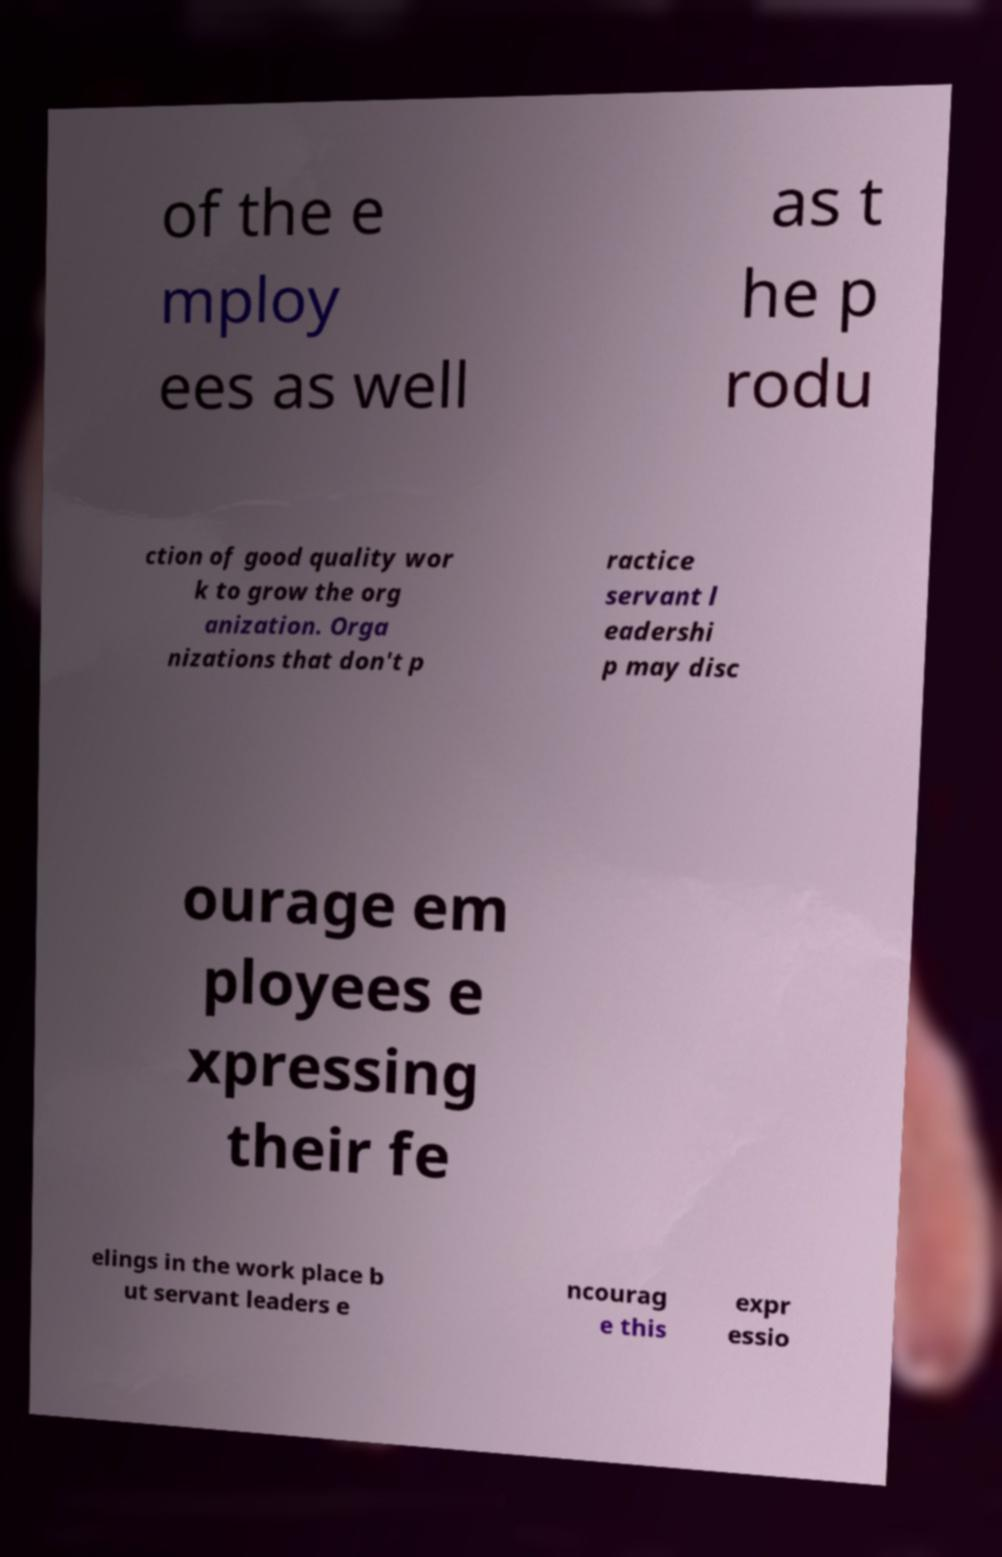There's text embedded in this image that I need extracted. Can you transcribe it verbatim? of the e mploy ees as well as t he p rodu ction of good quality wor k to grow the org anization. Orga nizations that don't p ractice servant l eadershi p may disc ourage em ployees e xpressing their fe elings in the work place b ut servant leaders e ncourag e this expr essio 